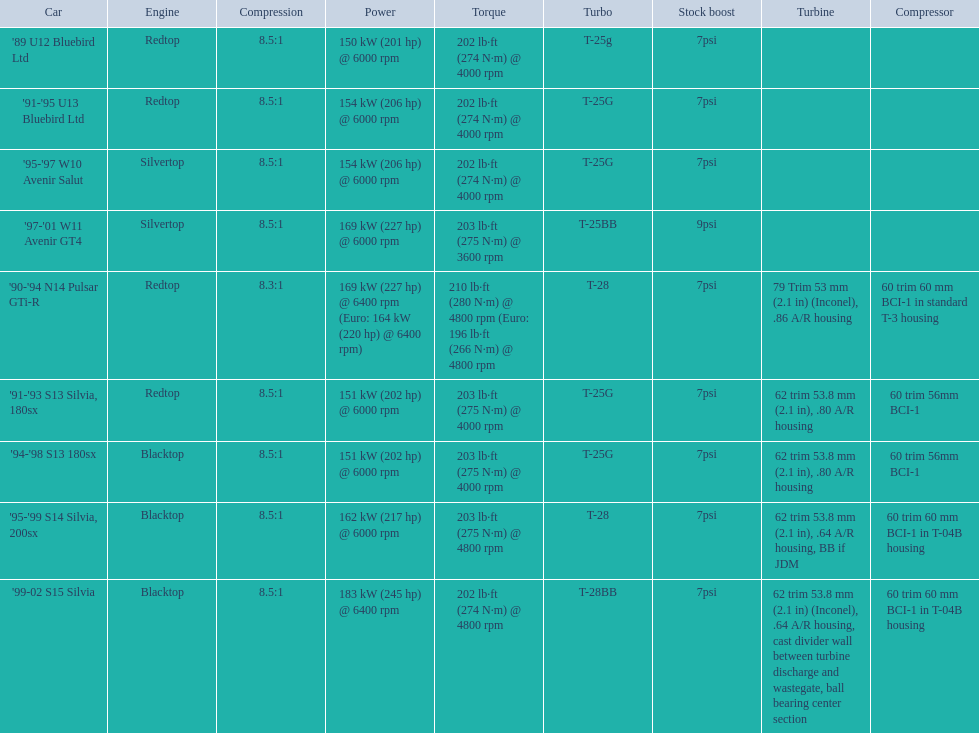Which engines were used after 1999? Silvertop, Blacktop. 